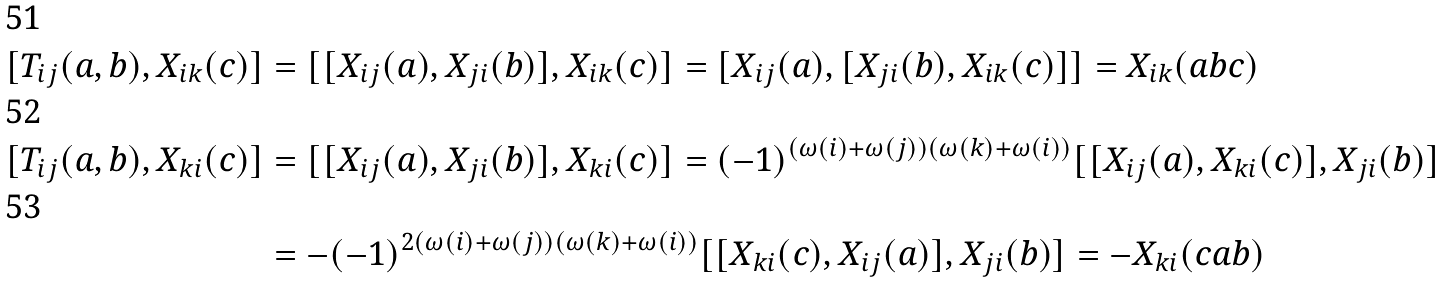<formula> <loc_0><loc_0><loc_500><loc_500>[ T _ { i j } ( a , b ) , X _ { i k } ( c ) ] & = [ [ X _ { i j } ( a ) , X _ { j i } ( b ) ] , X _ { i k } ( c ) ] = [ X _ { i j } ( a ) , [ X _ { j i } ( b ) , X _ { i k } ( c ) ] ] = X _ { i k } ( a b c ) \\ [ T _ { i j } ( a , b ) , X _ { k i } ( c ) ] & = [ [ X _ { i j } ( a ) , X _ { j i } ( b ) ] , X _ { k i } ( c ) ] = ( - 1 ) ^ { ( \omega ( i ) + \omega ( j ) ) ( \omega ( k ) + \omega ( i ) ) } [ [ X _ { i j } ( a ) , X _ { k i } ( c ) ] , X _ { j i } ( b ) ] \\ & = - ( - 1 ) ^ { 2 ( \omega ( i ) + \omega ( j ) ) ( \omega ( k ) + \omega ( i ) ) } [ [ X _ { k i } ( c ) , X _ { i j } ( a ) ] , X _ { j i } ( b ) ] = - X _ { k i } ( c a b )</formula> 